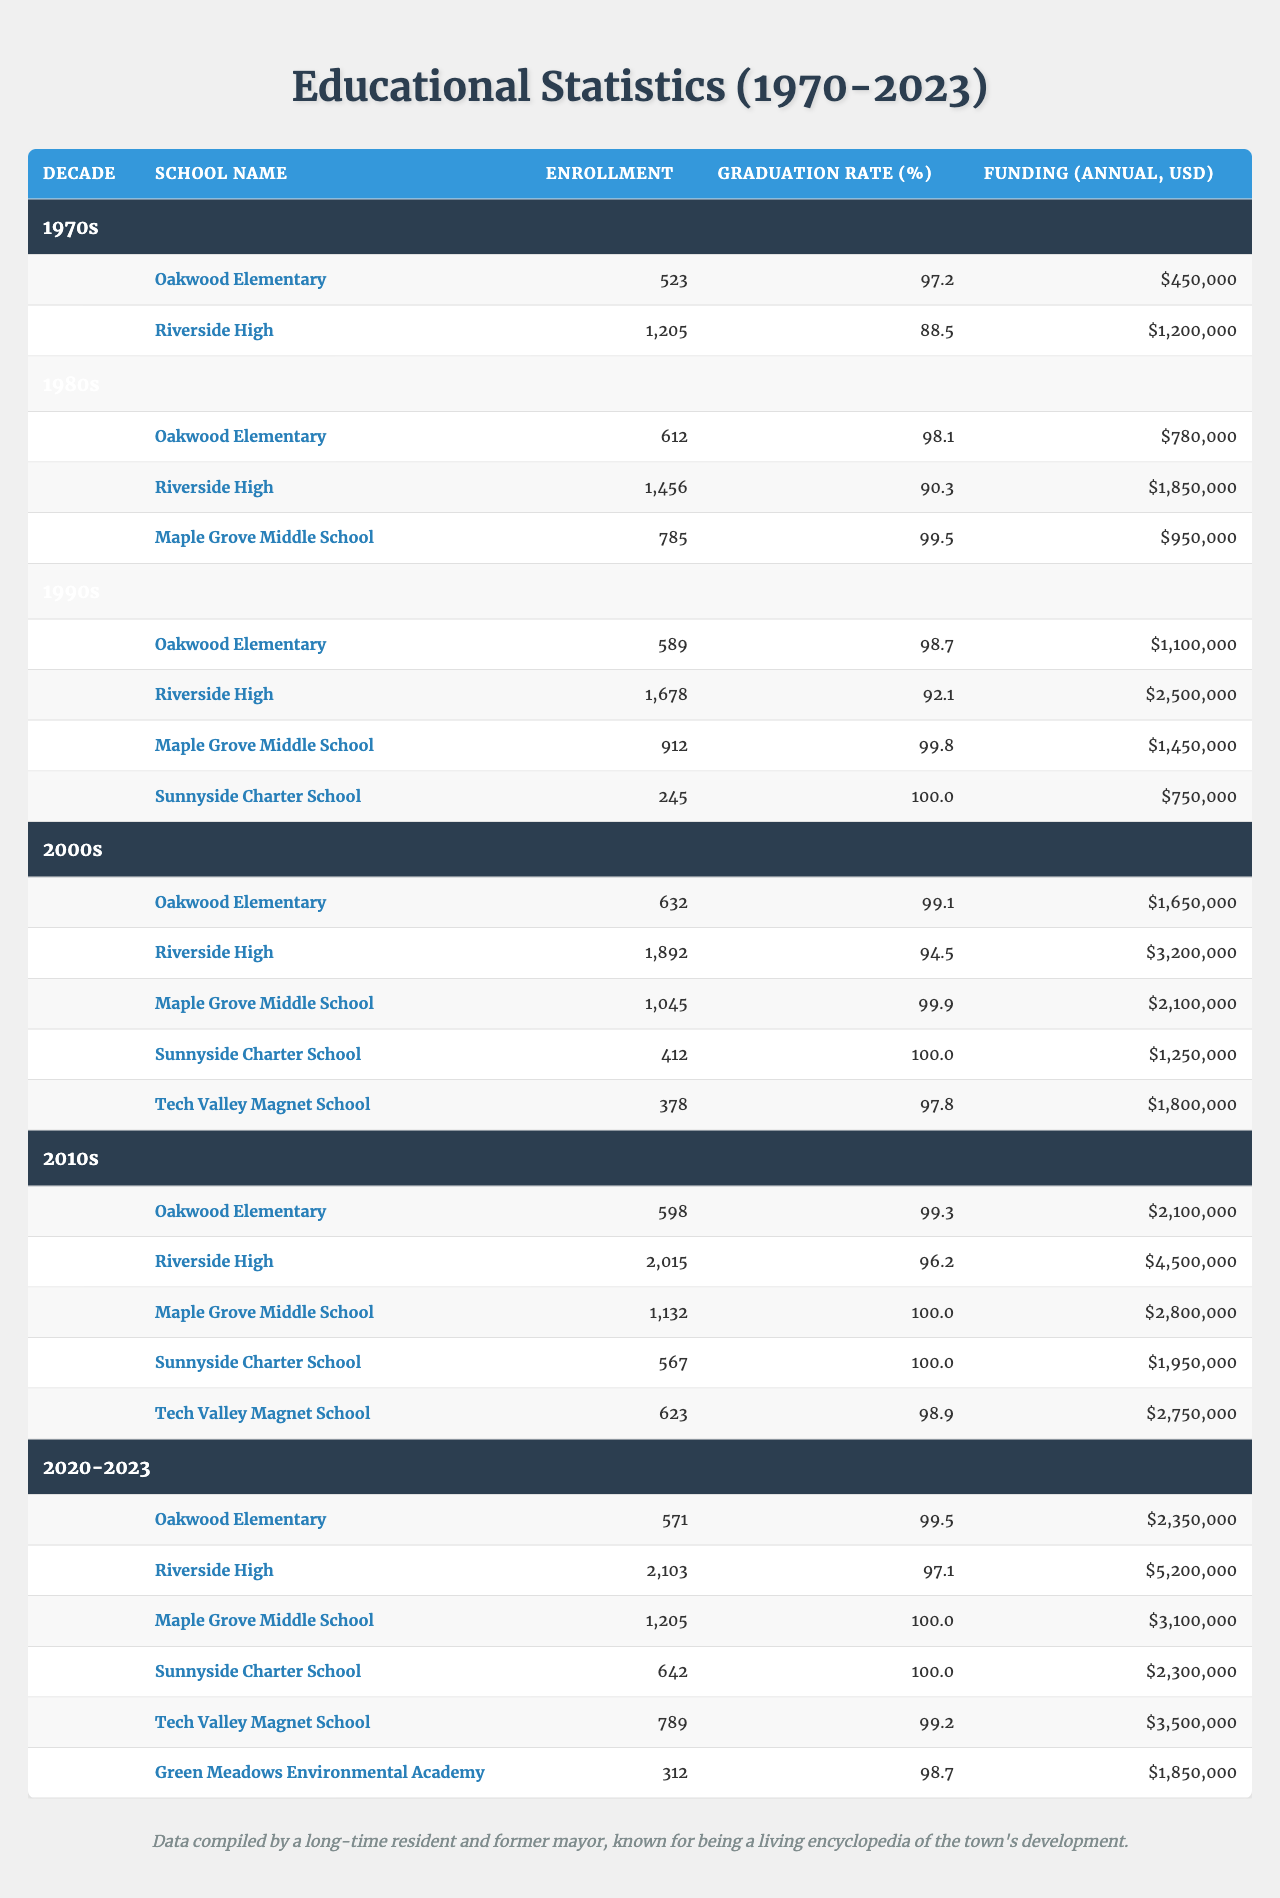What was the highest enrollment recorded at Riverside High School? By examining the table across the decades, the enrollment at Riverside High peaked in the 2020-2023 decade with 2,103 students.
Answer: 2,103 What is the graduation rate of Oakwood Elementary in the 1990s? The table shows that in the 1990s, Oakwood Elementary had a graduation rate of 98.7%.
Answer: 98.7% What is the total funding for all schools combined in the 1980s? The funding for each school in the 1980s is $780,000 (Oakwood) + $1,850,000 (Riverside) + $950,000 (Maple Grove) = $3,580,000.
Answer: $3,580,000 Which school had the lowest enrollment in the 2000s? Looking at the enrollment figures for the 2000s, Tech Valley Magnet School had the lowest enrollment with 378 students.
Answer: Tech Valley Magnet School Was the graduation rate at Sunnyside Charter School ever below 100%? Reviewing the data, Sunnyside Charter School maintained a graduation rate of 100% across all decades listed. Therefore, the statement is false.
Answer: No What is the percentage increase in enrollment for Oakwood Elementary from the 1970s to the 2020-2023 period? Enrollment increased from 523 to 571 from the 1970s to the 2020-2023 period. The percentage change is ((571 - 523) / 523) * 100 ≈ 9.2%.
Answer: 9.2% What was the average funding for Maple Grove Middle School across all decades? To find the average funding, we sum the funding over the decades: $950,000 (1980s) + $1,450,000 (1990s) + $2,100,000 (2000s) + $2,800,000 (2010s) + $3,100,000 (2020-2023) = $11,400,000. Dividing by 5 gives an average of $2,280,000.
Answer: $2,280,000 Which decade saw the highest graduation rate for Riverside High School? Examining the graduation rates for Riverside High, the 2010s decade recorded the highest rate at 96.2%.
Answer: 2010s How much more funding did Riverside High receive in the 2020-2023 decade compared to the 1990s? In the 2020-2023 decade, Riverside High received $5,200,000, while in the 1990s it received $2,500,000. The difference is $5,200,000 - $2,500,000 = $2,700,000.
Answer: $2,700,000 Is the enrollment for Green Meadows Environmental Academy included in every decade? Green Meadows Environmental Academy is only listed in the 2020-2023 period, so it does not appear in every decade. Thus, the statement is false.
Answer: No 